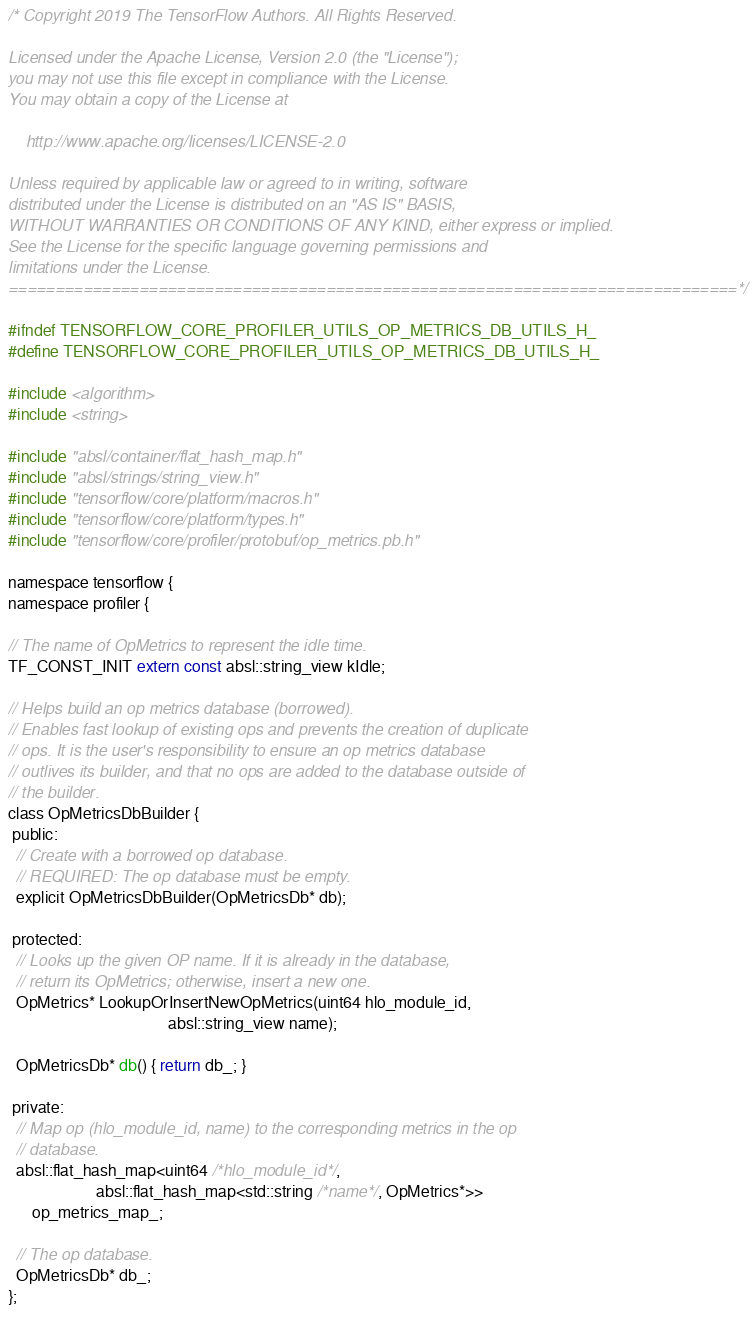<code> <loc_0><loc_0><loc_500><loc_500><_C_>/* Copyright 2019 The TensorFlow Authors. All Rights Reserved.

Licensed under the Apache License, Version 2.0 (the "License");
you may not use this file except in compliance with the License.
You may obtain a copy of the License at

    http://www.apache.org/licenses/LICENSE-2.0

Unless required by applicable law or agreed to in writing, software
distributed under the License is distributed on an "AS IS" BASIS,
WITHOUT WARRANTIES OR CONDITIONS OF ANY KIND, either express or implied.
See the License for the specific language governing permissions and
limitations under the License.
==============================================================================*/

#ifndef TENSORFLOW_CORE_PROFILER_UTILS_OP_METRICS_DB_UTILS_H_
#define TENSORFLOW_CORE_PROFILER_UTILS_OP_METRICS_DB_UTILS_H_

#include <algorithm>
#include <string>

#include "absl/container/flat_hash_map.h"
#include "absl/strings/string_view.h"
#include "tensorflow/core/platform/macros.h"
#include "tensorflow/core/platform/types.h"
#include "tensorflow/core/profiler/protobuf/op_metrics.pb.h"

namespace tensorflow {
namespace profiler {

// The name of OpMetrics to represent the idle time.
TF_CONST_INIT extern const absl::string_view kIdle;

// Helps build an op metrics database (borrowed).
// Enables fast lookup of existing ops and prevents the creation of duplicate
// ops. It is the user's responsibility to ensure an op metrics database
// outlives its builder, and that no ops are added to the database outside of
// the builder.
class OpMetricsDbBuilder {
 public:
  // Create with a borrowed op database.
  // REQUIRED: The op database must be empty.
  explicit OpMetricsDbBuilder(OpMetricsDb* db);

 protected:
  // Looks up the given OP name. If it is already in the database,
  // return its OpMetrics; otherwise, insert a new one.
  OpMetrics* LookupOrInsertNewOpMetrics(uint64 hlo_module_id,
                                        absl::string_view name);

  OpMetricsDb* db() { return db_; }

 private:
  // Map op (hlo_module_id, name) to the corresponding metrics in the op
  // database.
  absl::flat_hash_map<uint64 /*hlo_module_id*/,
                      absl::flat_hash_map<std::string /*name*/, OpMetrics*>>
      op_metrics_map_;

  // The op database.
  OpMetricsDb* db_;
};
</code> 